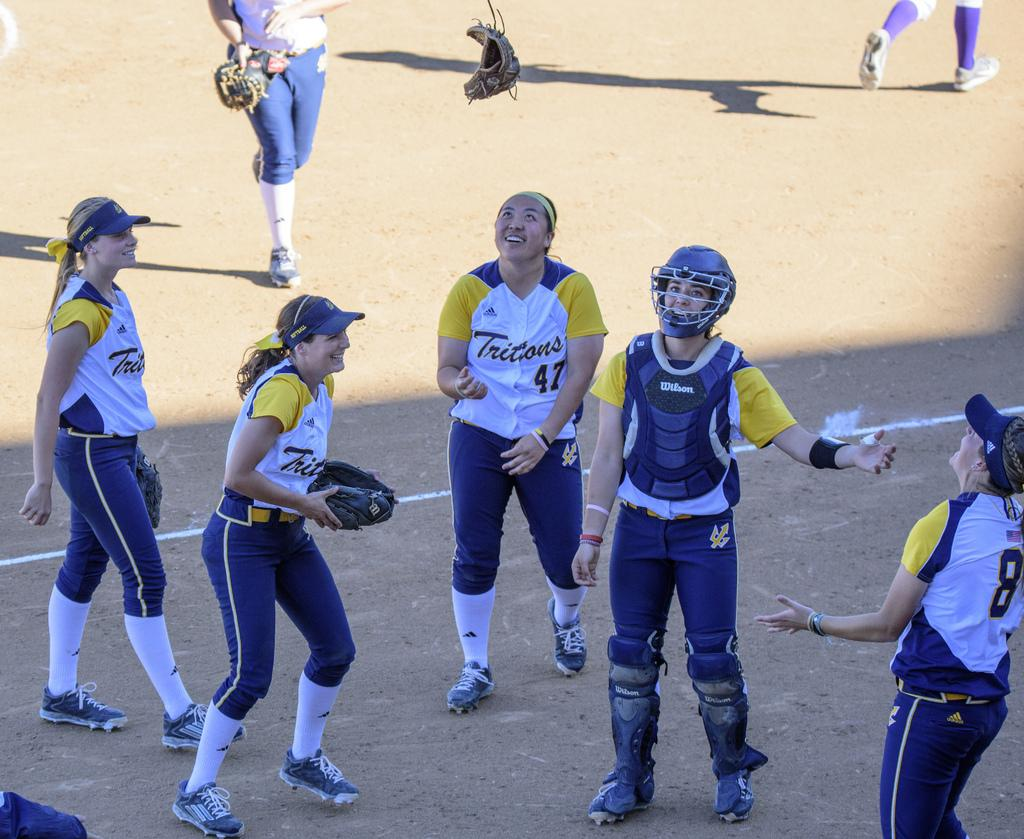<image>
Describe the image concisely. Softball players from the Tritons team are smiling in a circle. 